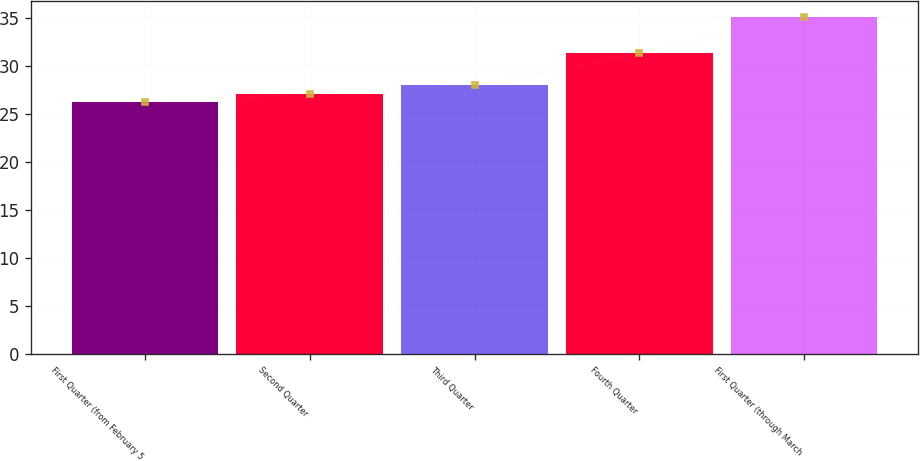Convert chart to OTSL. <chart><loc_0><loc_0><loc_500><loc_500><bar_chart><fcel>First Quarter (from February 5<fcel>Second Quarter<fcel>Third Quarter<fcel>Fourth Quarter<fcel>First Quarter (through March<nl><fcel>26.19<fcel>27.07<fcel>27.95<fcel>31.29<fcel>35.01<nl></chart> 